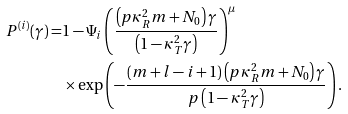<formula> <loc_0><loc_0><loc_500><loc_500>P ^ { ( i ) } ( \gamma ) = & 1 - \Psi _ { i } \left ( \frac { \left ( p \kappa ^ { 2 } _ { R } m + N _ { 0 } \right ) \gamma } { \left ( 1 - \kappa ^ { 2 } _ { T } \gamma \right ) } \right ) ^ { \mu } \\ & \times \exp \left ( - \frac { ( m + l - i + 1 ) \left ( p \kappa ^ { 2 } _ { R } m + N _ { 0 } \right ) \gamma } { p \left ( 1 - \kappa ^ { 2 } _ { T } \gamma \right ) } \right ) .</formula> 